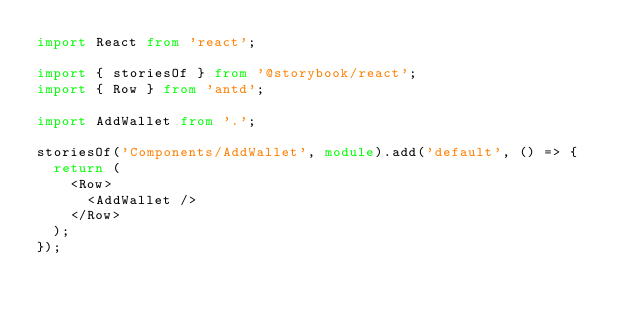<code> <loc_0><loc_0><loc_500><loc_500><_TypeScript_>import React from 'react';

import { storiesOf } from '@storybook/react';
import { Row } from 'antd';

import AddWallet from '.';

storiesOf('Components/AddWallet', module).add('default', () => {
  return (
    <Row>
      <AddWallet />
    </Row>
  );
});
</code> 